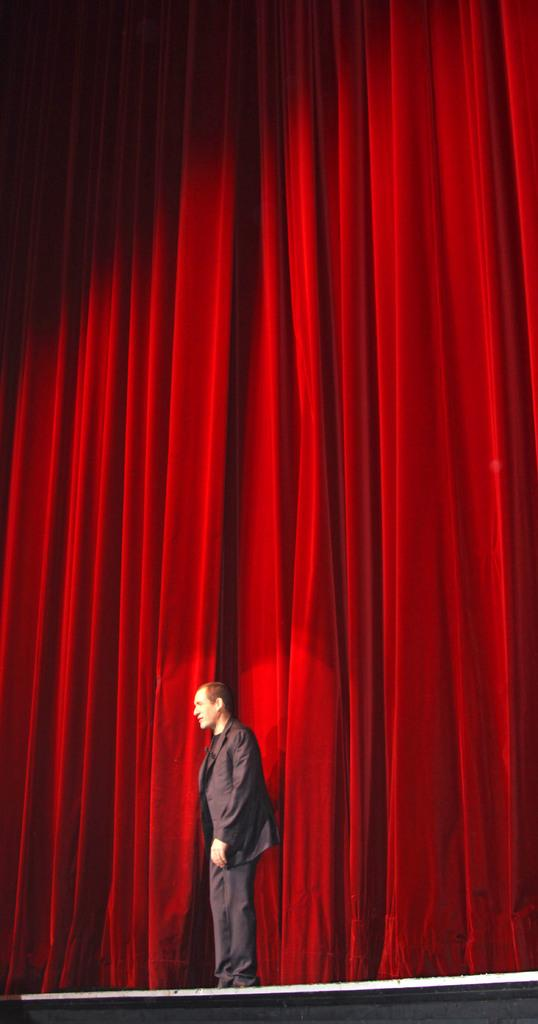Where was the image taken? The image is taken indoors. What can be seen in the background of the image? There are curtains in the background of the image. What is located at the bottom of the image? There is a dais at the bottom of the image. Who is present in the image? A man is standing on the dais in the middle of the image. What is the price of the hand in the image? There is no hand present in the image, and therefore no price can be determined. 